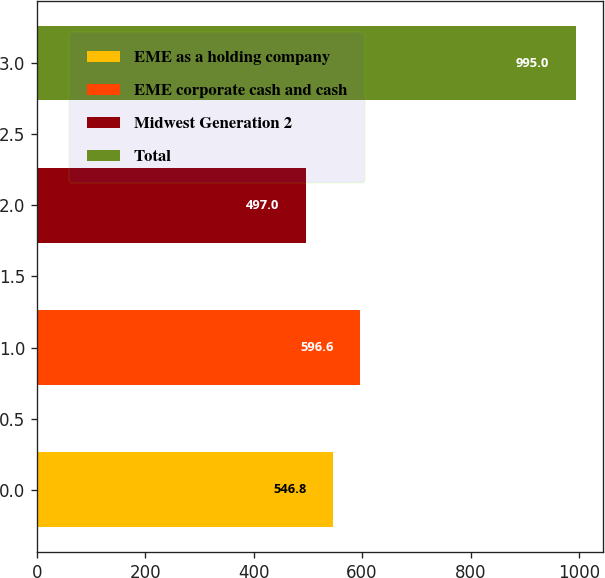Convert chart. <chart><loc_0><loc_0><loc_500><loc_500><bar_chart><fcel>EME as a holding company<fcel>EME corporate cash and cash<fcel>Midwest Generation 2<fcel>Total<nl><fcel>546.8<fcel>596.6<fcel>497<fcel>995<nl></chart> 